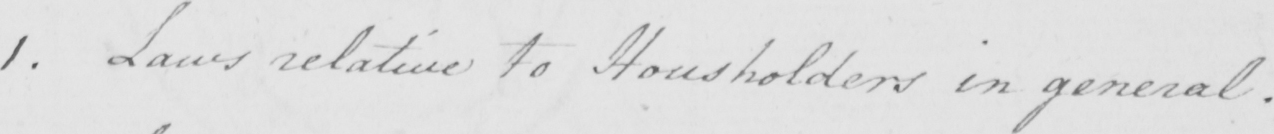What text is written in this handwritten line? 1 . Laws relative to Householders in general . 